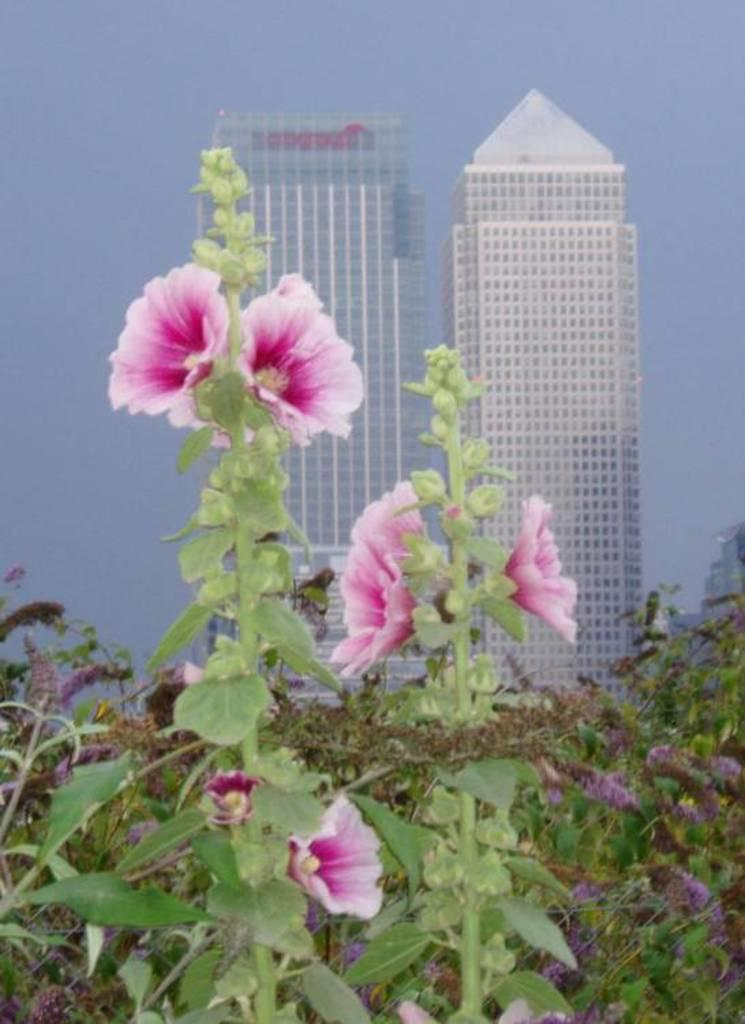What type of plants are in the foreground of the image? There are flower plants in the foreground of the image. What type of structures can be seen in the background of the image? There are tower buildings in the background of the image. What can be seen in the sky in the image? Clouds are visible in the sky. What type of linen can be seen hanging from the tower buildings in the image? There is no linen visible in the image, and it does not appear to be hanging from the tower buildings. 